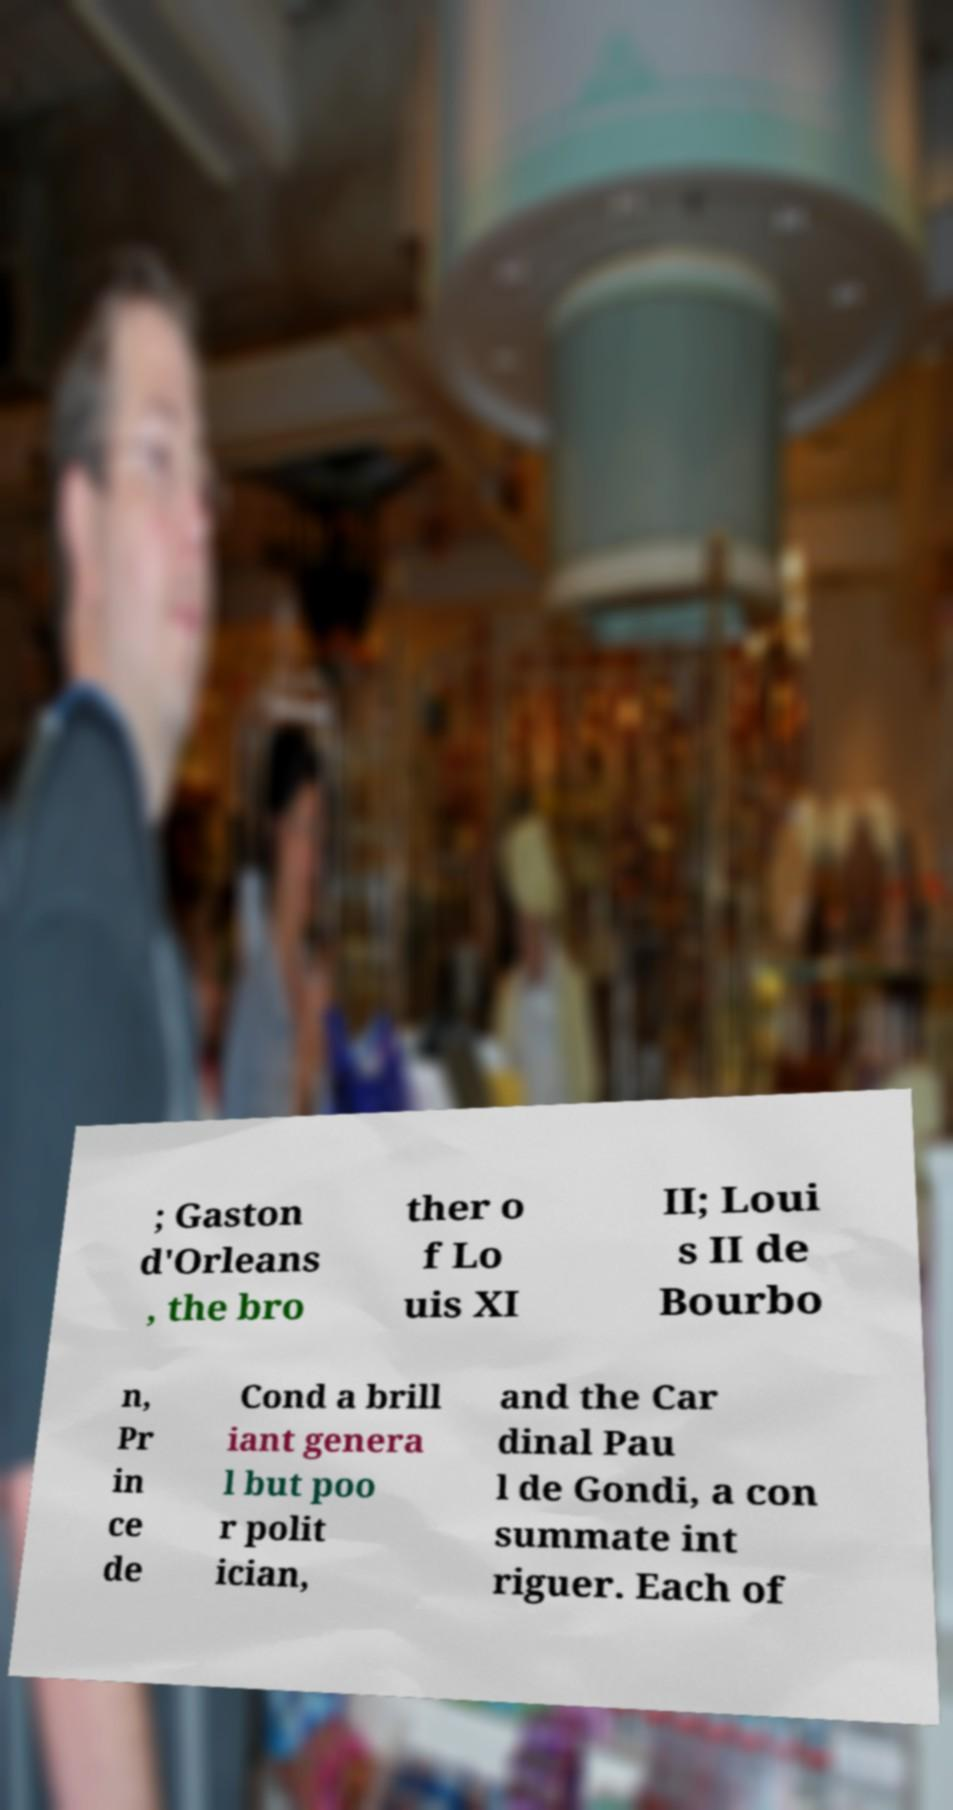I need the written content from this picture converted into text. Can you do that? ; Gaston d'Orleans , the bro ther o f Lo uis XI II; Loui s II de Bourbo n, Pr in ce de Cond a brill iant genera l but poo r polit ician, and the Car dinal Pau l de Gondi, a con summate int riguer. Each of 